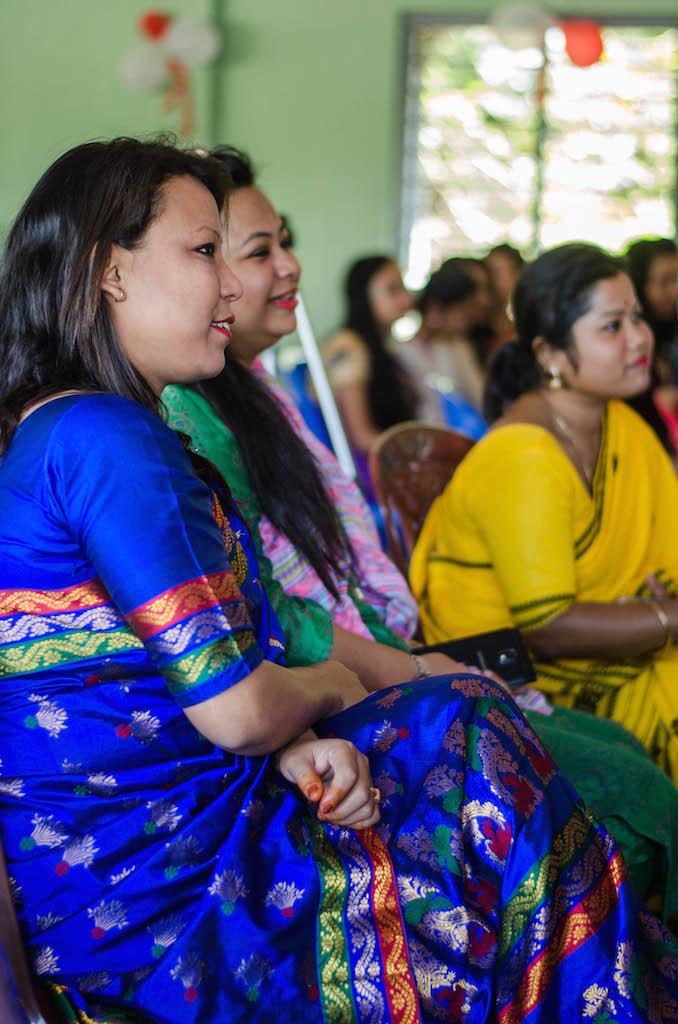Can you describe this image briefly? In this image I can see the group of people sitting on the chairs. These people are wearing the different color dresses. In the background I can see the green color wall and the window but it is blurry. 